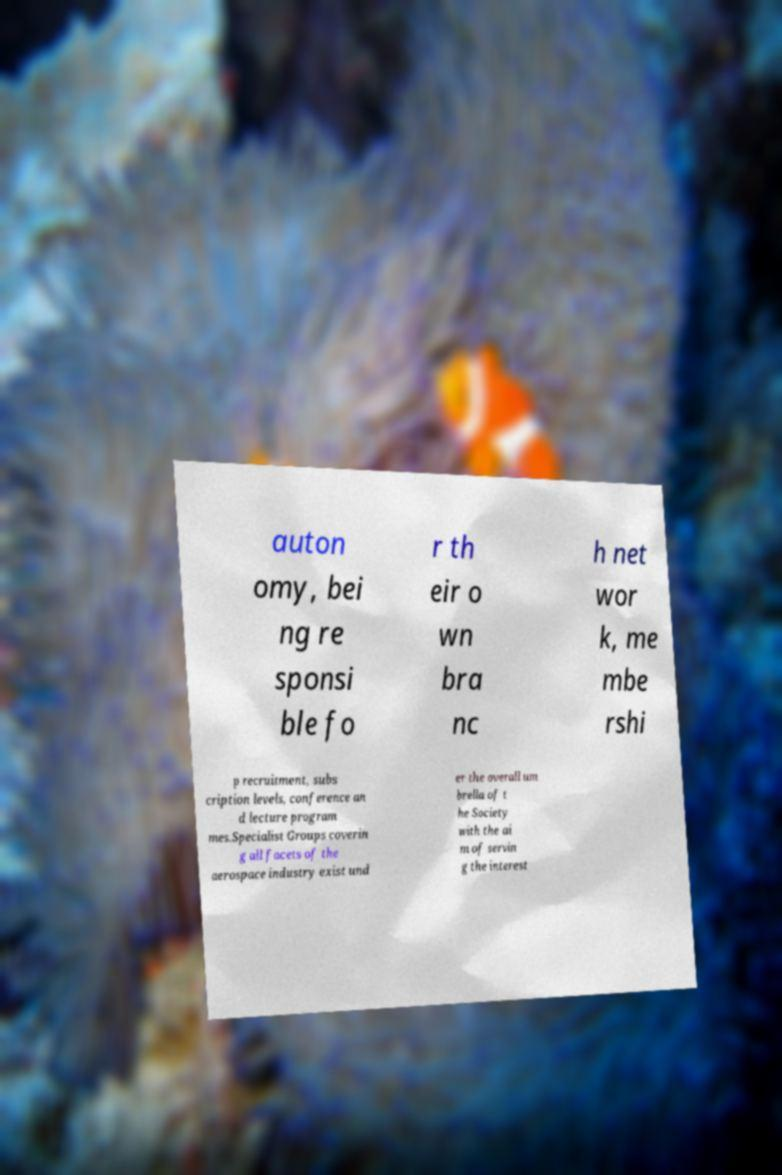I need the written content from this picture converted into text. Can you do that? auton omy, bei ng re sponsi ble fo r th eir o wn bra nc h net wor k, me mbe rshi p recruitment, subs cription levels, conference an d lecture program mes.Specialist Groups coverin g all facets of the aerospace industry exist und er the overall um brella of t he Society with the ai m of servin g the interest 